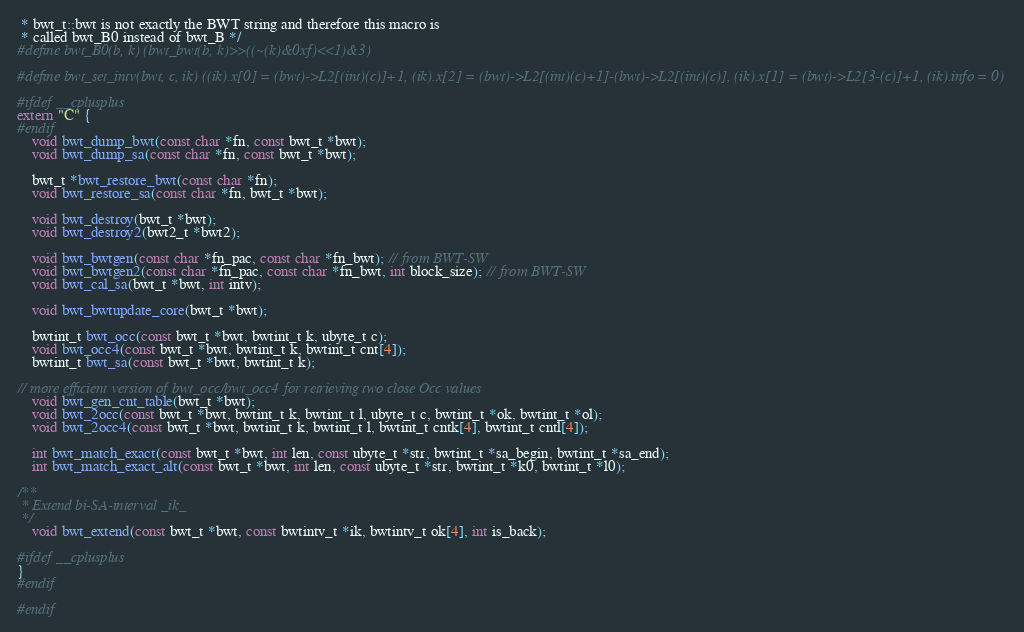Convert code to text. <code><loc_0><loc_0><loc_500><loc_500><_C_> * bwt_t::bwt is not exactly the BWT string and therefore this macro is
 * called bwt_B0 instead of bwt_B */
#define bwt_B0(b, k) (bwt_bwt(b, k)>>((~(k)&0xf)<<1)&3)

#define bwt_set_intv(bwt, c, ik) ((ik).x[0] = (bwt)->L2[(int)(c)]+1, (ik).x[2] = (bwt)->L2[(int)(c)+1]-(bwt)->L2[(int)(c)], (ik).x[1] = (bwt)->L2[3-(c)]+1, (ik).info = 0)

#ifdef __cplusplus
extern "C" {
#endif
    void bwt_dump_bwt(const char *fn, const bwt_t *bwt);
    void bwt_dump_sa(const char *fn, const bwt_t *bwt);

    bwt_t *bwt_restore_bwt(const char *fn);
    void bwt_restore_sa(const char *fn, bwt_t *bwt);

    void bwt_destroy(bwt_t *bwt);
    void bwt_destroy2(bwt2_t *bwt2);
	
    void bwt_bwtgen(const char *fn_pac, const char *fn_bwt); // from BWT-SW
    void bwt_bwtgen2(const char *fn_pac, const char *fn_bwt, int block_size); // from BWT-SW
    void bwt_cal_sa(bwt_t *bwt, int intv);

    void bwt_bwtupdate_core(bwt_t *bwt);

    bwtint_t bwt_occ(const bwt_t *bwt, bwtint_t k, ubyte_t c);
    void bwt_occ4(const bwt_t *bwt, bwtint_t k, bwtint_t cnt[4]);
    bwtint_t bwt_sa(const bwt_t *bwt, bwtint_t k);

// more efficient version of bwt_occ/bwt_occ4 for retrieving two close Occ values
    void bwt_gen_cnt_table(bwt_t *bwt);
    void bwt_2occ(const bwt_t *bwt, bwtint_t k, bwtint_t l, ubyte_t c, bwtint_t *ok, bwtint_t *ol);
    void bwt_2occ4(const bwt_t *bwt, bwtint_t k, bwtint_t l, bwtint_t cntk[4], bwtint_t cntl[4]);

    int bwt_match_exact(const bwt_t *bwt, int len, const ubyte_t *str, bwtint_t *sa_begin, bwtint_t *sa_end);
    int bwt_match_exact_alt(const bwt_t *bwt, int len, const ubyte_t *str, bwtint_t *k0, bwtint_t *l0);

/**
 * Extend bi-SA-interval _ik_
 */
    void bwt_extend(const bwt_t *bwt, const bwtintv_t *ik, bwtintv_t ok[4], int is_back);

#ifdef __cplusplus
}
#endif

#endif
</code> 